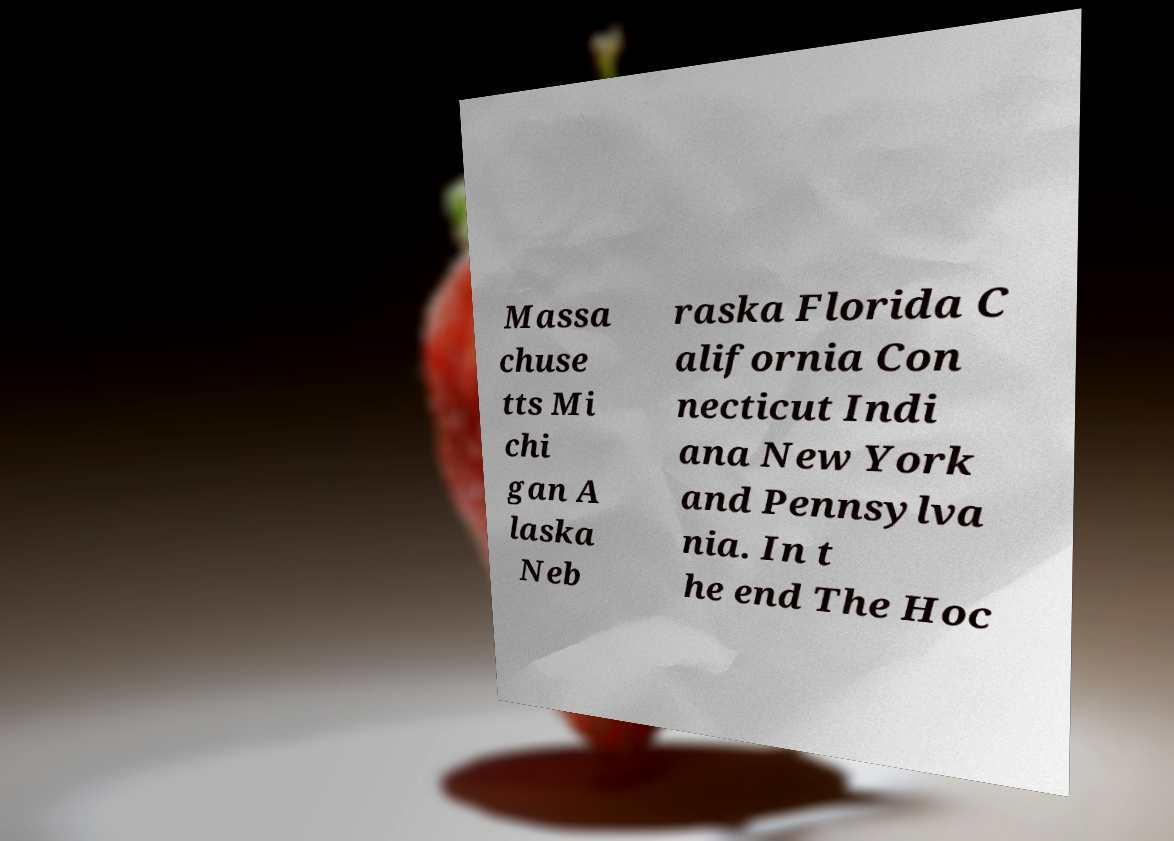Can you read and provide the text displayed in the image?This photo seems to have some interesting text. Can you extract and type it out for me? Massa chuse tts Mi chi gan A laska Neb raska Florida C alifornia Con necticut Indi ana New York and Pennsylva nia. In t he end The Hoc 